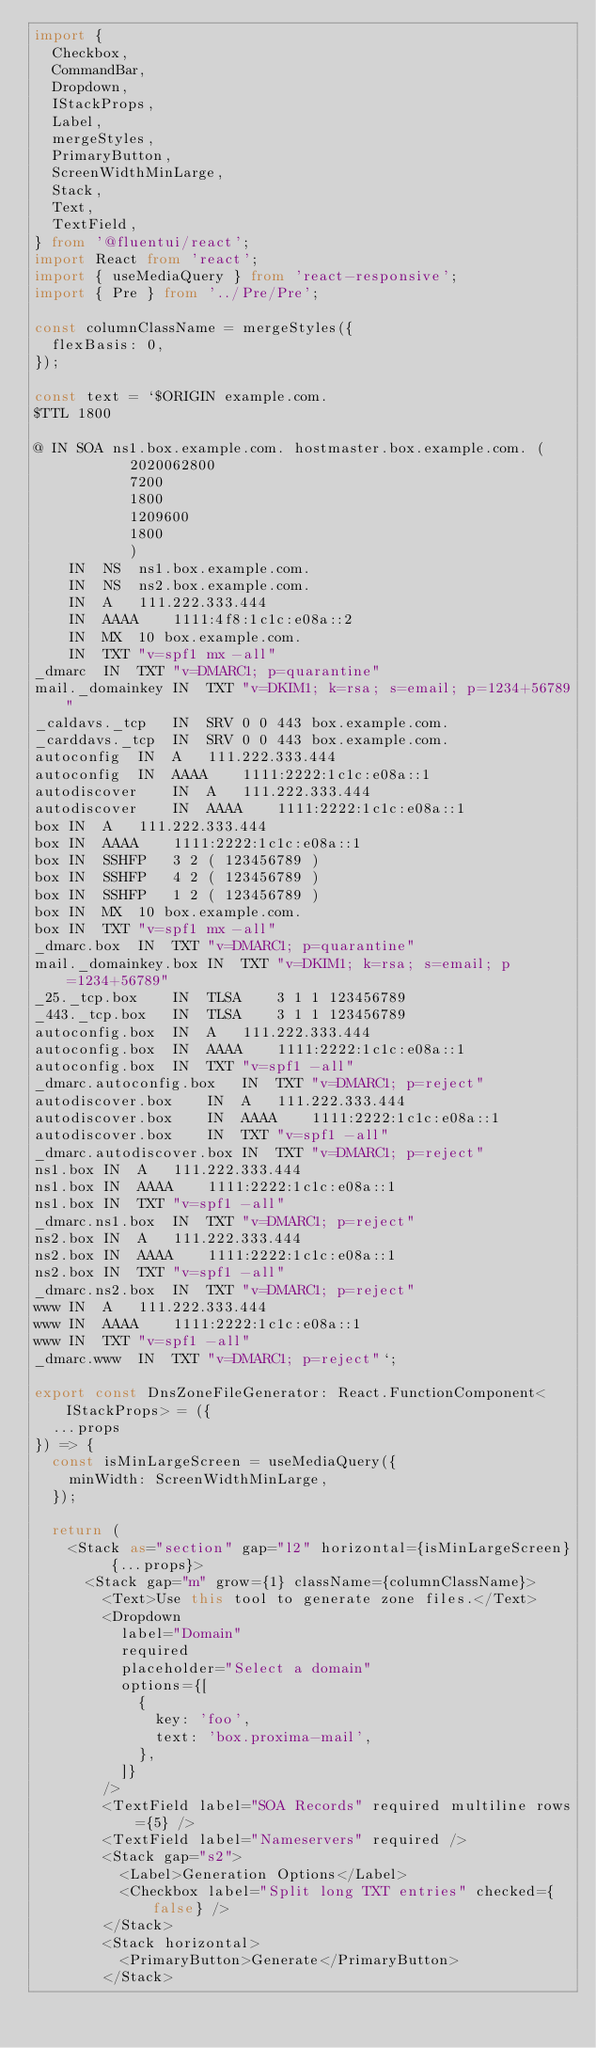<code> <loc_0><loc_0><loc_500><loc_500><_TypeScript_>import {
  Checkbox,
  CommandBar,
  Dropdown,
  IStackProps,
  Label,
  mergeStyles,
  PrimaryButton,
  ScreenWidthMinLarge,
  Stack,
  Text,
  TextField,
} from '@fluentui/react';
import React from 'react';
import { useMediaQuery } from 'react-responsive';
import { Pre } from '../Pre/Pre';

const columnClassName = mergeStyles({
  flexBasis: 0,
});

const text = `$ORIGIN example.com.
$TTL 1800

@ IN SOA ns1.box.example.com. hostmaster.box.example.com. (
           2020062800
           7200
           1800
           1209600
           1800
           )
	IN	NS	ns1.box.example.com.
	IN	NS	ns2.box.example.com.
	IN	A	111.222.333.444
	IN	AAAA	1111:4f8:1c1c:e08a::2
	IN	MX	10 box.example.com.
	IN	TXT	"v=spf1 mx -all"
_dmarc	IN	TXT	"v=DMARC1; p=quarantine"
mail._domainkey	IN	TXT	"v=DKIM1; k=rsa; s=email; p=1234+56789"
_caldavs._tcp	IN	SRV	0 0 443 box.example.com.
_carddavs._tcp	IN	SRV	0 0 443 box.example.com.
autoconfig	IN	A	111.222.333.444
autoconfig	IN	AAAA	1111:2222:1c1c:e08a::1
autodiscover	IN	A	111.222.333.444
autodiscover	IN	AAAA	1111:2222:1c1c:e08a::1
box	IN	A	111.222.333.444
box	IN	AAAA	1111:2222:1c1c:e08a::1
box	IN	SSHFP	3 2 ( 123456789 )
box	IN	SSHFP	4 2 ( 123456789 )
box	IN	SSHFP	1 2 ( 123456789 )
box	IN	MX	10 box.example.com.
box	IN	TXT	"v=spf1 mx -all"
_dmarc.box	IN	TXT	"v=DMARC1; p=quarantine"
mail._domainkey.box	IN	TXT	"v=DKIM1; k=rsa; s=email; p=1234+56789"
_25._tcp.box	IN	TLSA	3 1 1 123456789
_443._tcp.box	IN	TLSA	3 1 1 123456789
autoconfig.box	IN	A	111.222.333.444
autoconfig.box	IN	AAAA	1111:2222:1c1c:e08a::1
autoconfig.box	IN	TXT	"v=spf1 -all"
_dmarc.autoconfig.box	IN	TXT	"v=DMARC1; p=reject"
autodiscover.box	IN	A	111.222.333.444
autodiscover.box	IN	AAAA	1111:2222:1c1c:e08a::1
autodiscover.box	IN	TXT	"v=spf1 -all"
_dmarc.autodiscover.box	IN	TXT	"v=DMARC1; p=reject"
ns1.box	IN	A	111.222.333.444
ns1.box	IN	AAAA	1111:2222:1c1c:e08a::1
ns1.box	IN	TXT	"v=spf1 -all"
_dmarc.ns1.box	IN	TXT	"v=DMARC1; p=reject"
ns2.box	IN	A	111.222.333.444
ns2.box	IN	AAAA	1111:2222:1c1c:e08a::1
ns2.box	IN	TXT	"v=spf1 -all"
_dmarc.ns2.box	IN	TXT	"v=DMARC1; p=reject"
www	IN	A	111.222.333.444
www	IN	AAAA	1111:2222:1c1c:e08a::1
www	IN	TXT	"v=spf1 -all"
_dmarc.www	IN	TXT	"v=DMARC1; p=reject"`;

export const DnsZoneFileGenerator: React.FunctionComponent<IStackProps> = ({
  ...props
}) => {
  const isMinLargeScreen = useMediaQuery({
    minWidth: ScreenWidthMinLarge,
  });

  return (
    <Stack as="section" gap="l2" horizontal={isMinLargeScreen} {...props}>
      <Stack gap="m" grow={1} className={columnClassName}>
        <Text>Use this tool to generate zone files.</Text>
        <Dropdown
          label="Domain"
          required
          placeholder="Select a domain"
          options={[
            {
              key: 'foo',
              text: 'box.proxima-mail',
            },
          ]}
        />
        <TextField label="SOA Records" required multiline rows={5} />
        <TextField label="Nameservers" required />
        <Stack gap="s2">
          <Label>Generation Options</Label>
          <Checkbox label="Split long TXT entries" checked={false} />
        </Stack>
        <Stack horizontal>
          <PrimaryButton>Generate</PrimaryButton>
        </Stack></code> 